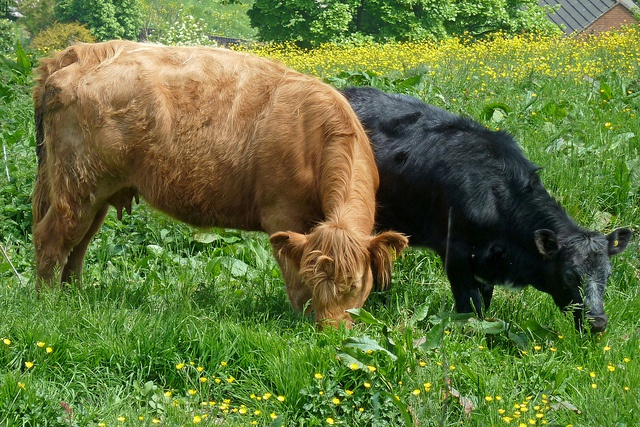Describe the objects in this image and their specific colors. I can see cow in darkgreen, olive, maroon, black, and tan tones and cow in darkgreen, black, gray, purple, and darkblue tones in this image. 